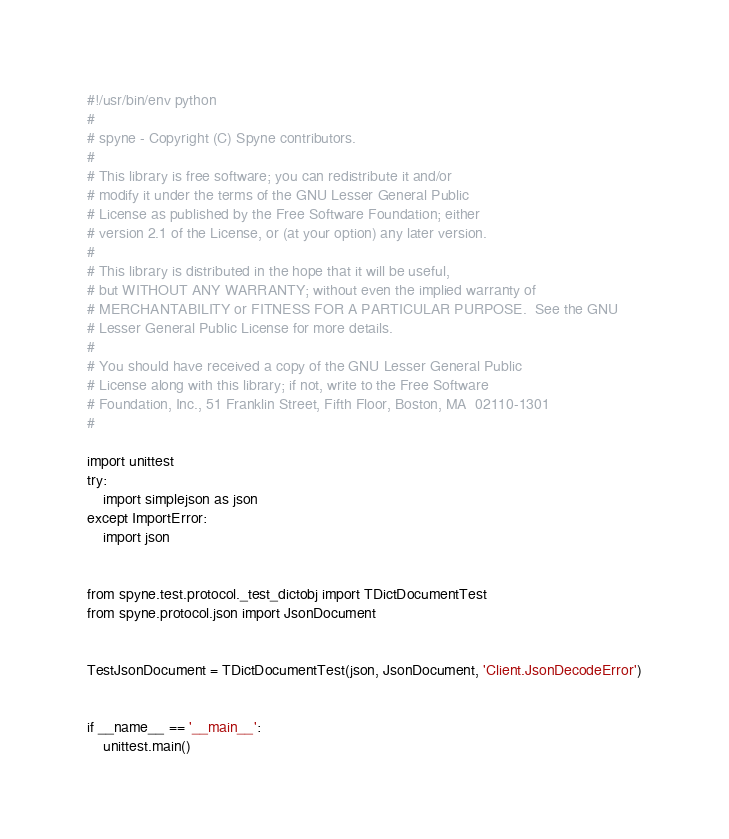Convert code to text. <code><loc_0><loc_0><loc_500><loc_500><_Python_>#!/usr/bin/env python
#
# spyne - Copyright (C) Spyne contributors.
#
# This library is free software; you can redistribute it and/or
# modify it under the terms of the GNU Lesser General Public
# License as published by the Free Software Foundation; either
# version 2.1 of the License, or (at your option) any later version.
#
# This library is distributed in the hope that it will be useful,
# but WITHOUT ANY WARRANTY; without even the implied warranty of
# MERCHANTABILITY or FITNESS FOR A PARTICULAR PURPOSE.  See the GNU
# Lesser General Public License for more details.
#
# You should have received a copy of the GNU Lesser General Public
# License along with this library; if not, write to the Free Software
# Foundation, Inc., 51 Franklin Street, Fifth Floor, Boston, MA  02110-1301
#

import unittest
try:
    import simplejson as json
except ImportError:
    import json


from spyne.test.protocol._test_dictobj import TDictDocumentTest
from spyne.protocol.json import JsonDocument


TestJsonDocument = TDictDocumentTest(json, JsonDocument, 'Client.JsonDecodeError')


if __name__ == '__main__':
    unittest.main()
</code> 